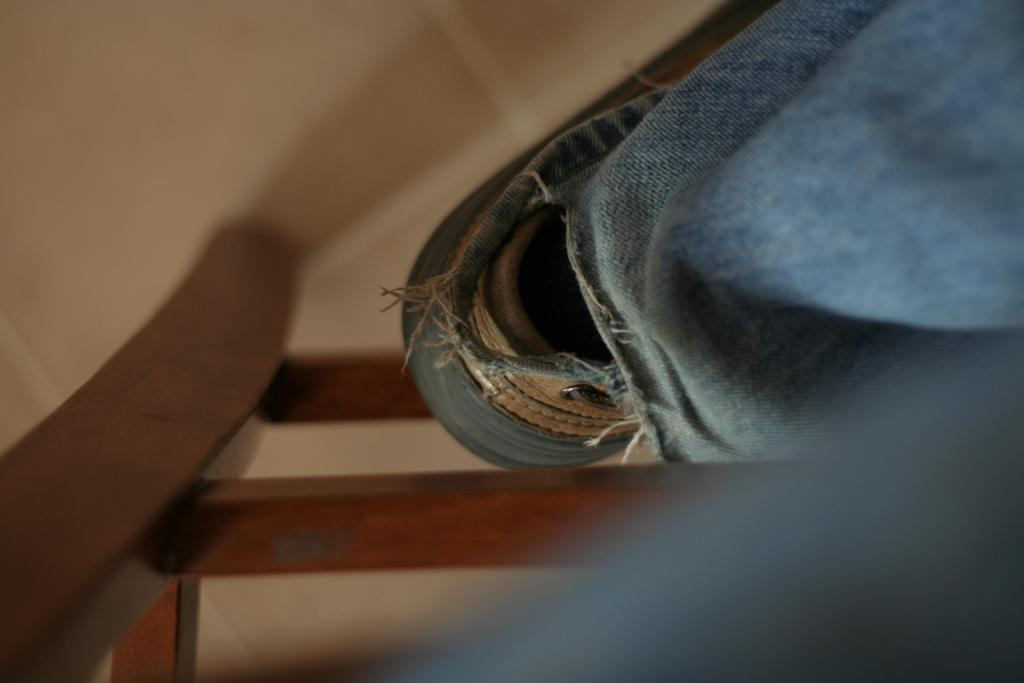What is located on the floor in the image? There is an object on the floor. What type of material is covering the floor? There is cloth on the floor. What is the other object made of that is on the floor? There is a wooden object on the floor. How many legs can be seen on the object in the image? There is no information about legs or the number of legs on any object in the image. 